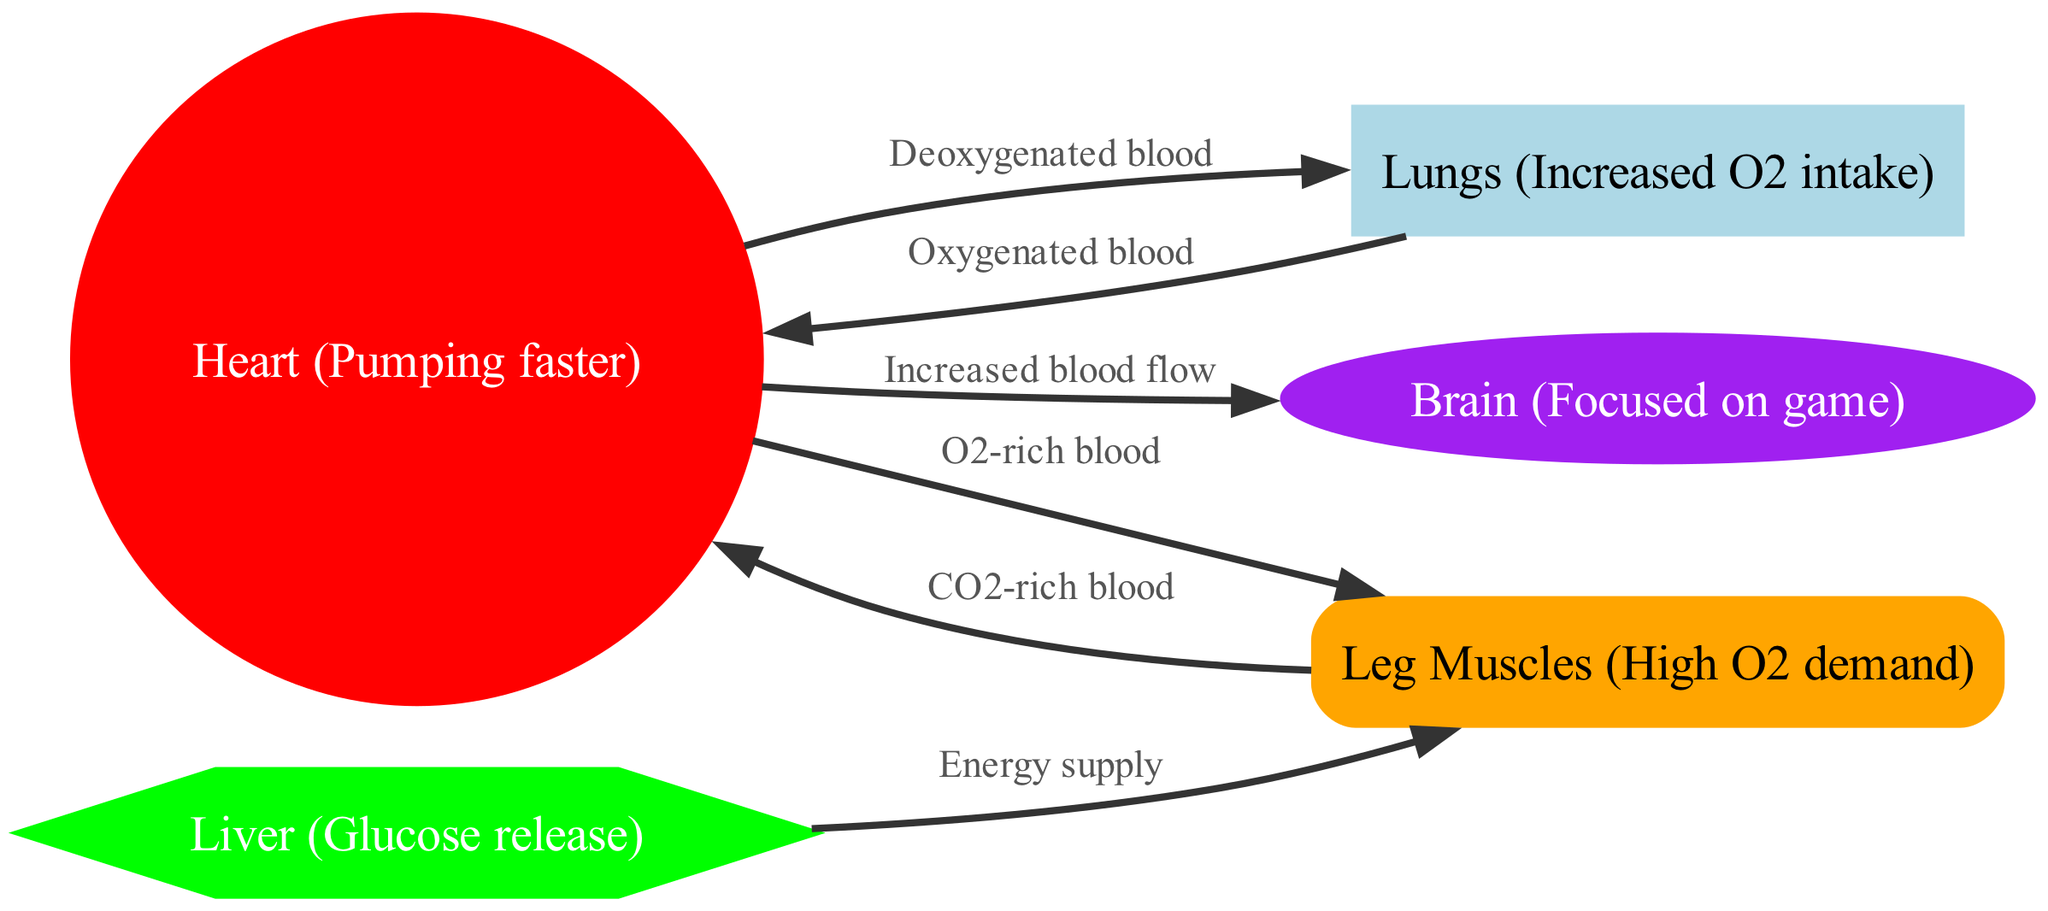What is the shape of the heart node? The heart node is represented as a circle, as specified in the node styles.
Answer: circle How many nodes are present in the diagram? Counting all unique entities in the "nodes" section, there are five nodes: heart, lungs, muscles, brain, and liver.
Answer: 5 What type of blood does the heart pump to the muscles? The edge connecting the heart to the muscles is labeled "O2-rich blood," indicating the type of blood flowing from the heart to the muscles.
Answer: O2-rich blood Which organ is responsible for glucose release? The liver node is explicitly labeled as "Liver (Glucose release)," indicating that it is the organ involved in glucose release within the diagram.
Answer: Liver What is the connection between the lungs and the heart? There are two connections: "Deoxygenated blood" flows from the heart to the lungs, and "Oxygenated blood" flows from the lungs back to the heart. Thus, the relationship is bi-directional.
Answer: Deoxygenated and Oxygenated blood What is the role of the liver in this cardiovascular system during exercise? The liver node specifies it has an "Energy supply" function that connects to the muscles, showing its supportive role in providing energy during exercise.
Answer: Energy supply What happens to blood from the muscles? The edge from muscles to the heart is labeled "CO2-rich blood," meaning the blood returning from the muscles to the heart is rich in carbon dioxide.
Answer: CO2-rich blood Which organ receives increased blood flow during intense exercise? The arrow from the heart to the brain indicates "Increased blood flow," illustrating that during intense exercise, the brain receives more blood flow.
Answer: Brain What does the lungs node indicate about oxygen intake? The lungs node is labeled "Increased O2 intake," showing that its function in the diagram is to intake more oxygen during exercise.
Answer: Increased O2 intake 